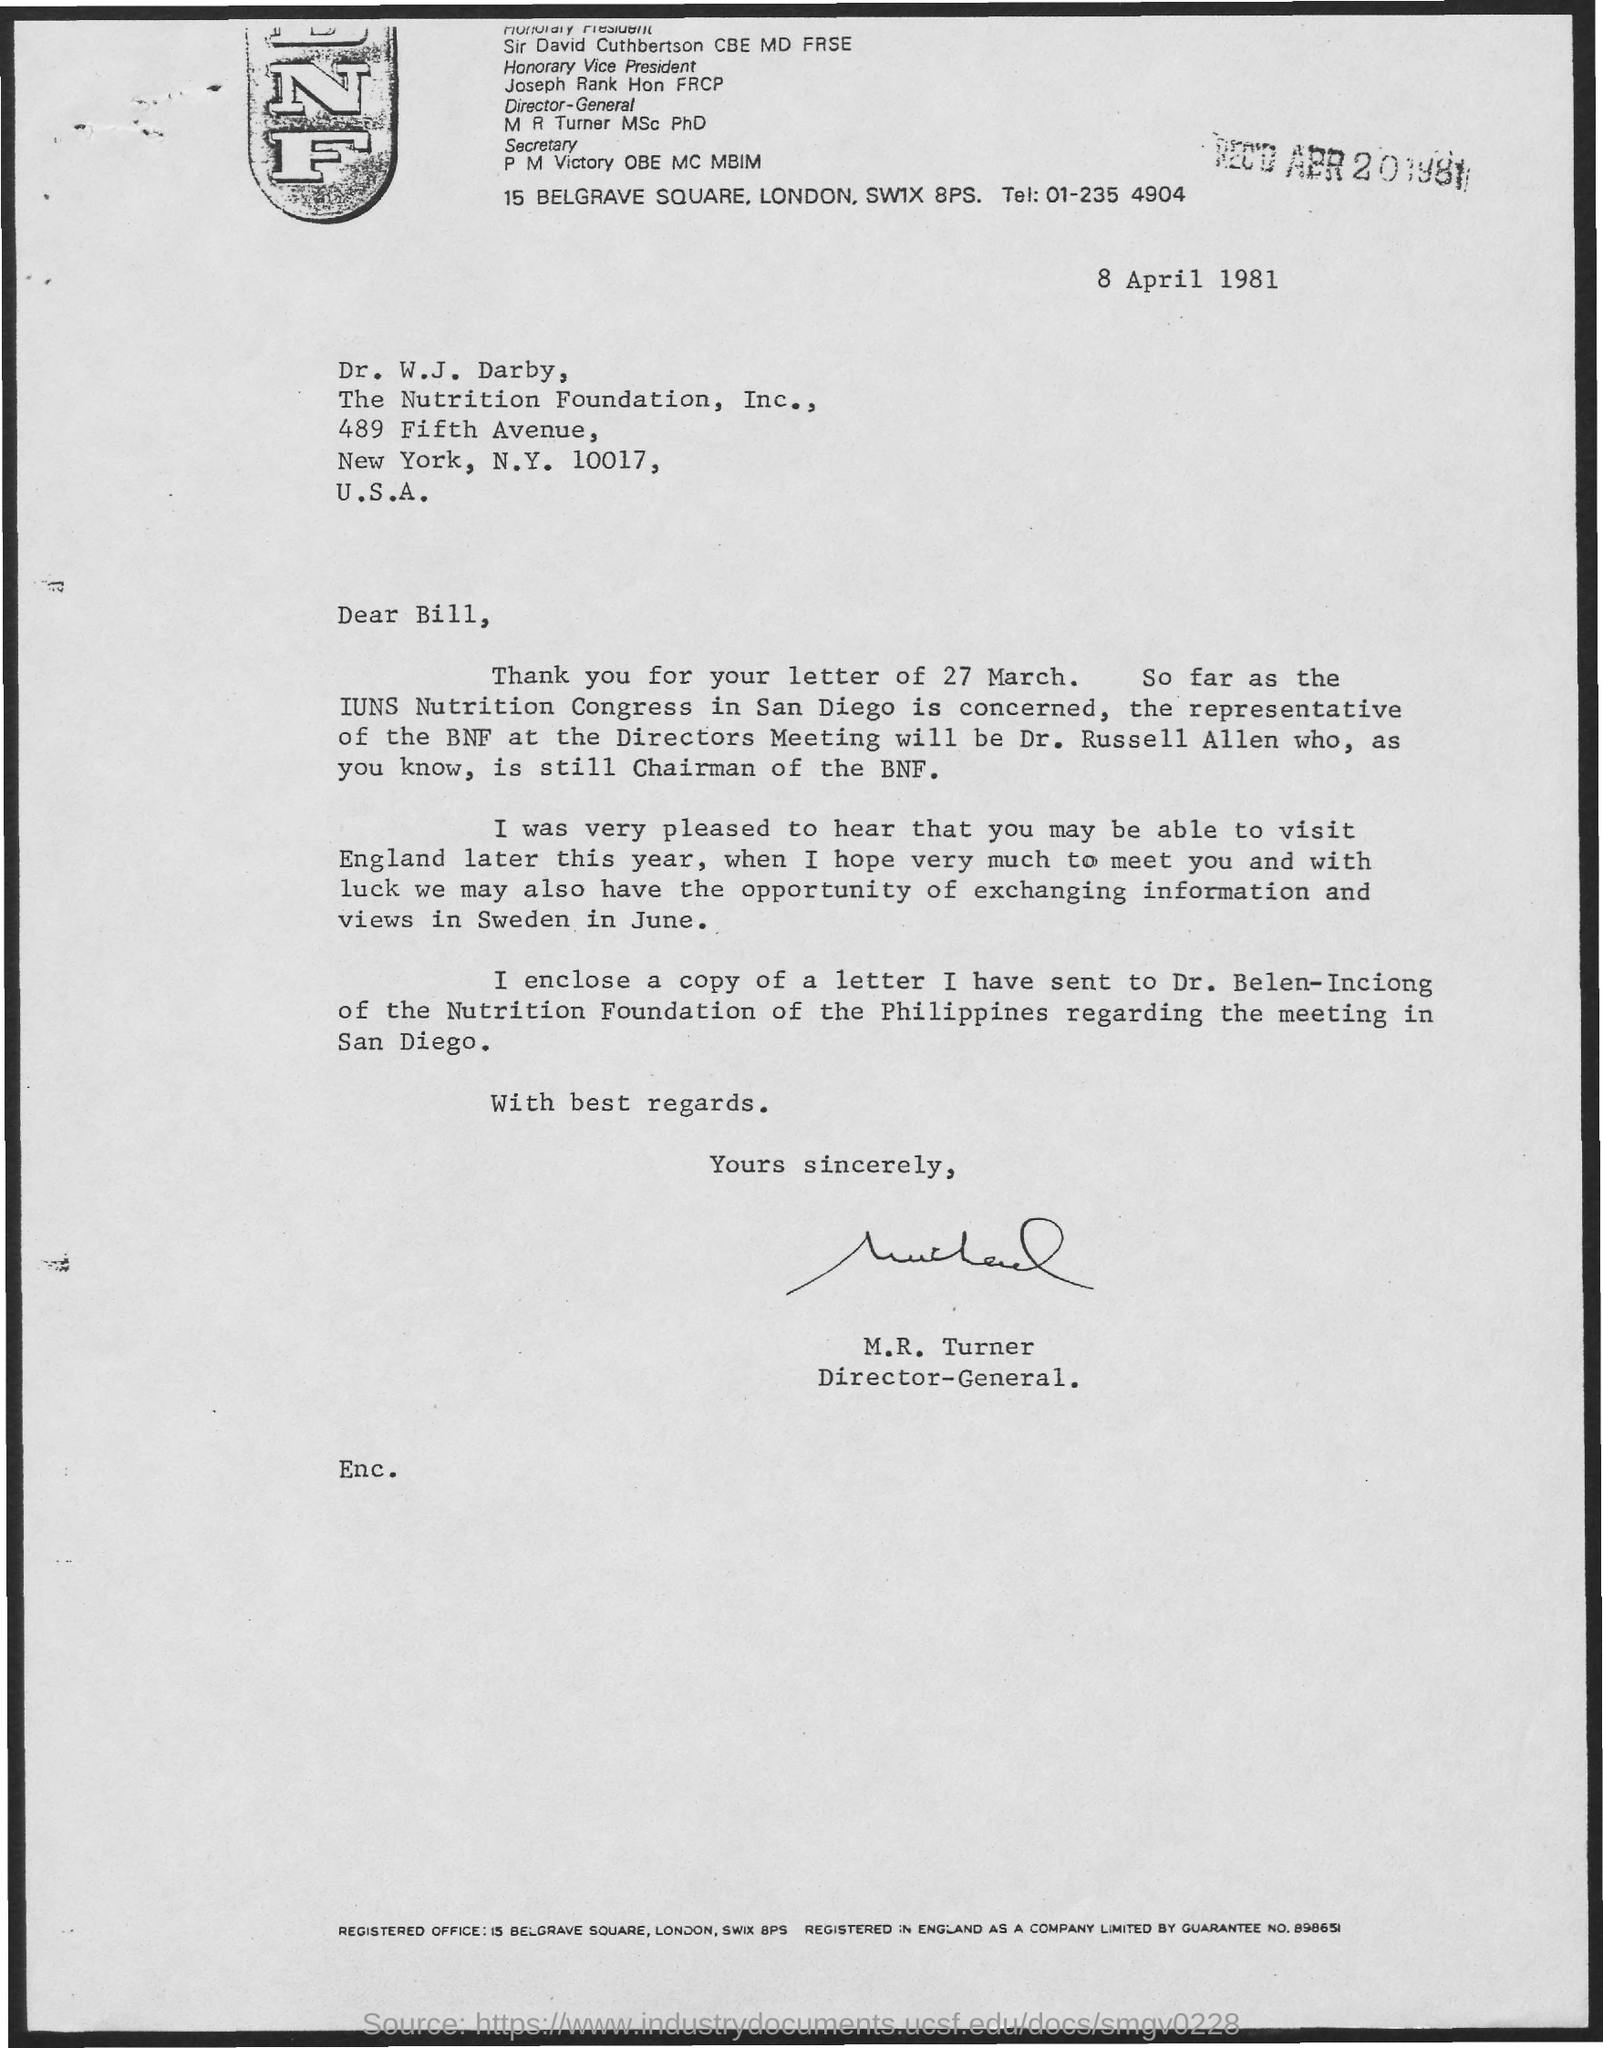What is the date on the document?
Provide a succinct answer. 8 April 1981. Who is the Representative of the BNF at the Directors meeting?
Offer a very short reply. DR. RUSSELL ALLEN. Who is this letter from?
Make the answer very short. M.R. TURNER. 